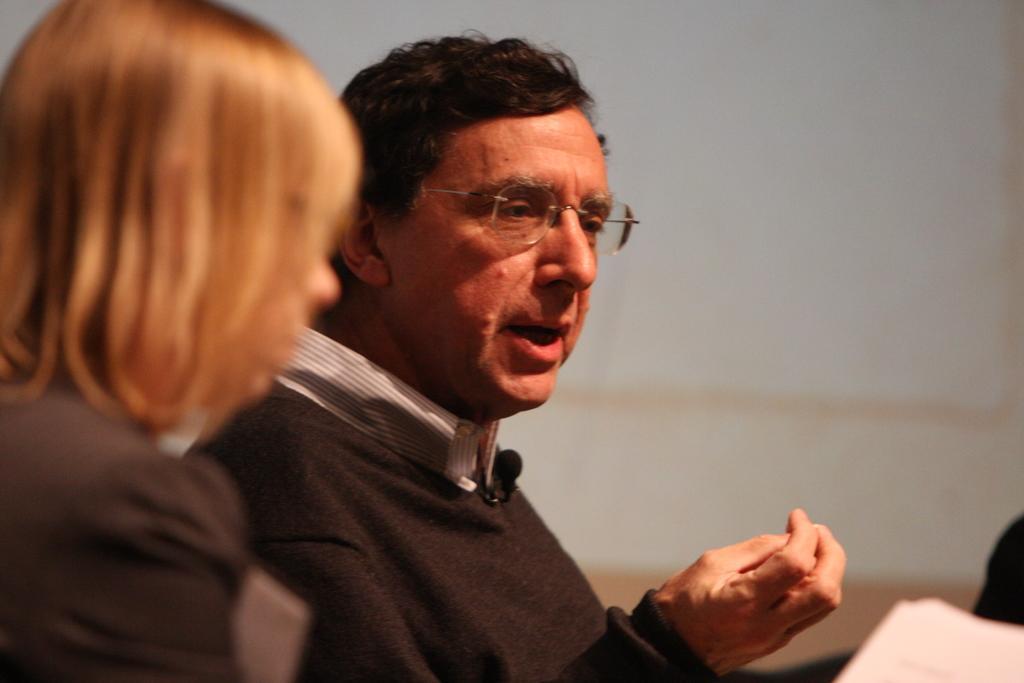Describe this image in one or two sentences. In this image I can see two persons and I can see both of them are wearing black colour dress. I can also see one of them is wearing a specs and on the right bottom side of this image I can see a white colour thing. I can also see this image is little bit blurry. 